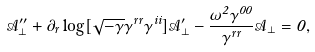Convert formula to latex. <formula><loc_0><loc_0><loc_500><loc_500>\mathcal { A } _ { \perp } ^ { \prime \prime } + \partial _ { r } \log [ \sqrt { - \gamma } \gamma ^ { r r } \gamma ^ { i i } ] \mathcal { A } _ { \perp } ^ { \prime } - \frac { \omega ^ { 2 } \gamma ^ { 0 0 } } { \gamma ^ { r r } } \mathcal { A } _ { \perp } = 0 ,</formula> 